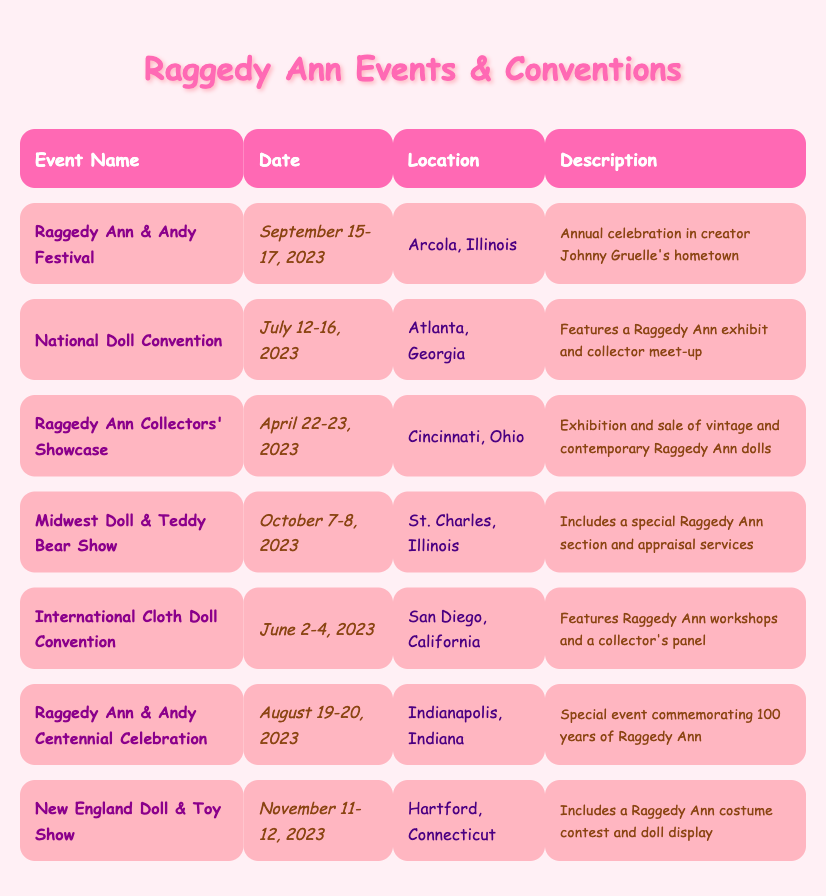What is the date of the Raggedy Ann & Andy Festival? The specific date for the Raggedy Ann & Andy Festival is listed in the table under the "Date" column for that event. It shows September 15-17, 2023.
Answer: September 15-17, 2023 Where is the National Doll Convention taking place? The location for the National Doll Convention can be found in the "Location" column for that event in the table. It indicates that the event will be held in Atlanta, Georgia.
Answer: Atlanta, Georgia How many events are happening in 2023? To find the number of events in 2023, count the rows in the table. There are 7 events listed, all occurring in the year 2023.
Answer: 7 Is there a Raggedy Ann costume contest at any event? The table mentions a costume contest in the description of the New England Doll & Toy Show, confirming that there is indeed a Raggedy Ann costume contest at this event.
Answer: Yes Which two events are scheduled for October 2023? We refer to the table and identify the events listed in the month of October. The two events are the Midwest Doll & Teddy Bear Show on October 7-8, 2023, and the New England Doll & Toy Show on November 11-12, 2023. As only one event is in October, this counts as October event.
Answer: Midwest Doll & Teddy Bear Show What is the earliest event date listed in the table? To find the earliest event date, the "Date" column needs to be compared. The earliest date in the table is April 22-23, 2023, from the Raggedy Ann Collectors' Showcase.
Answer: April 22-23, 2023 How many events take place in Illinois? By examining the "Location" column, we can see that there are three events in Illinois: the Raggedy Ann & Andy Festival in Arcola, the Midwest Doll & Teddy Bear Show in St. Charles, and another event on the list. Thus, the total is checked.
Answer: 3 